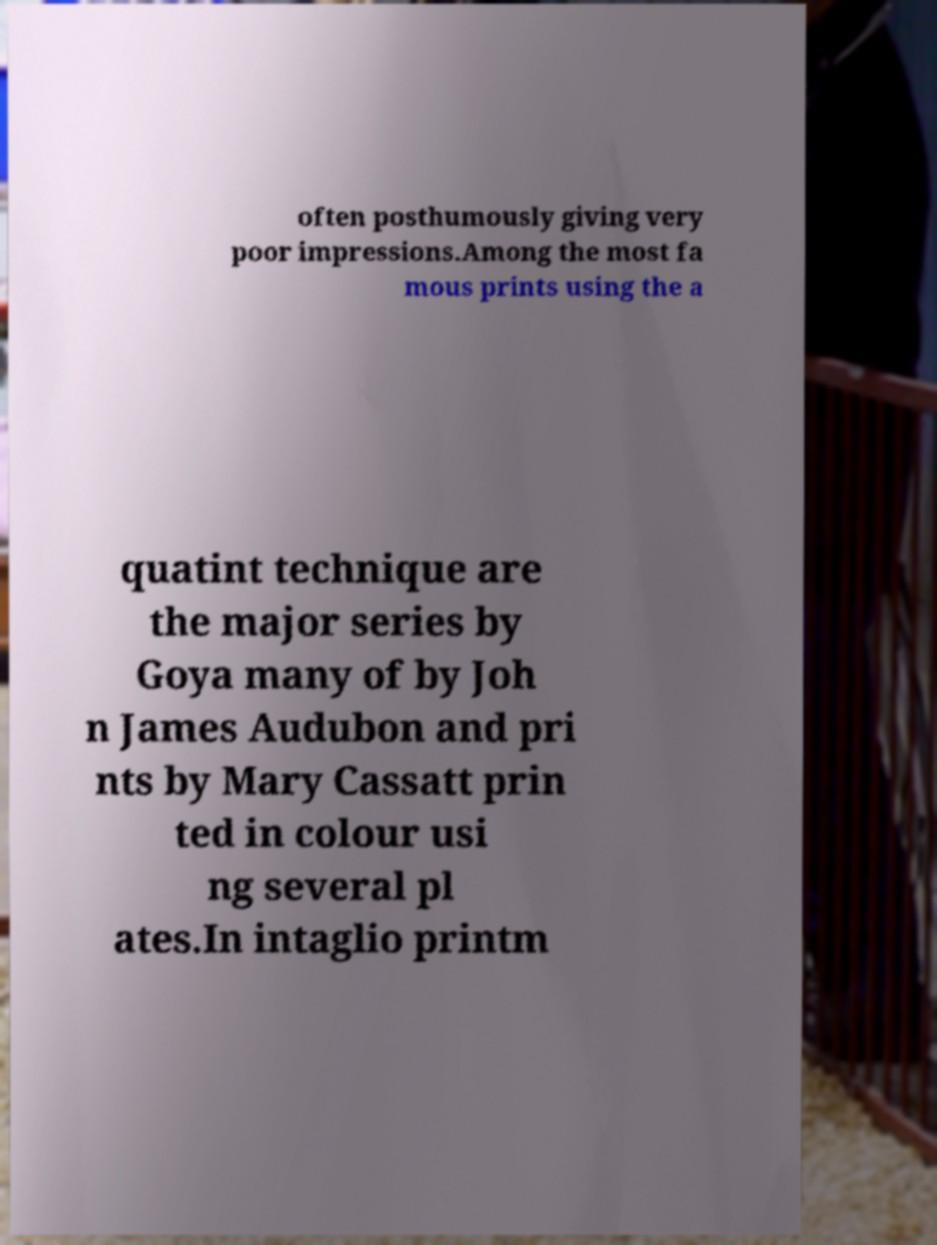What messages or text are displayed in this image? I need them in a readable, typed format. often posthumously giving very poor impressions.Among the most fa mous prints using the a quatint technique are the major series by Goya many of by Joh n James Audubon and pri nts by Mary Cassatt prin ted in colour usi ng several pl ates.In intaglio printm 